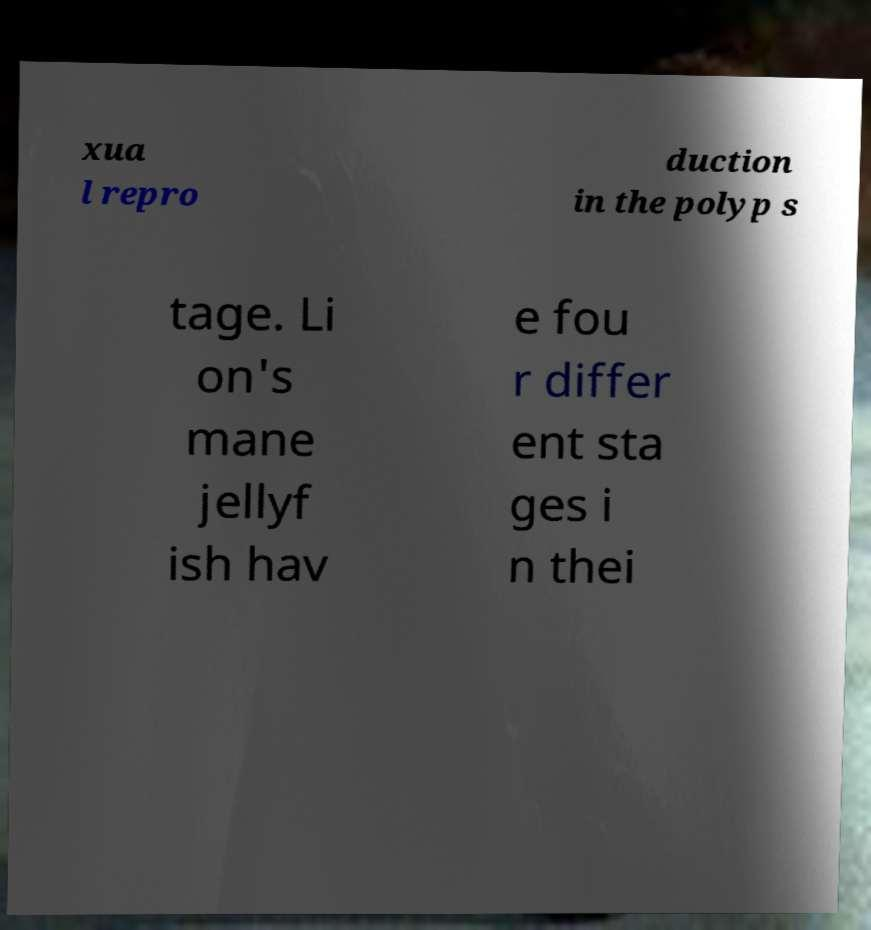Could you assist in decoding the text presented in this image and type it out clearly? xua l repro duction in the polyp s tage. Li on's mane jellyf ish hav e fou r differ ent sta ges i n thei 